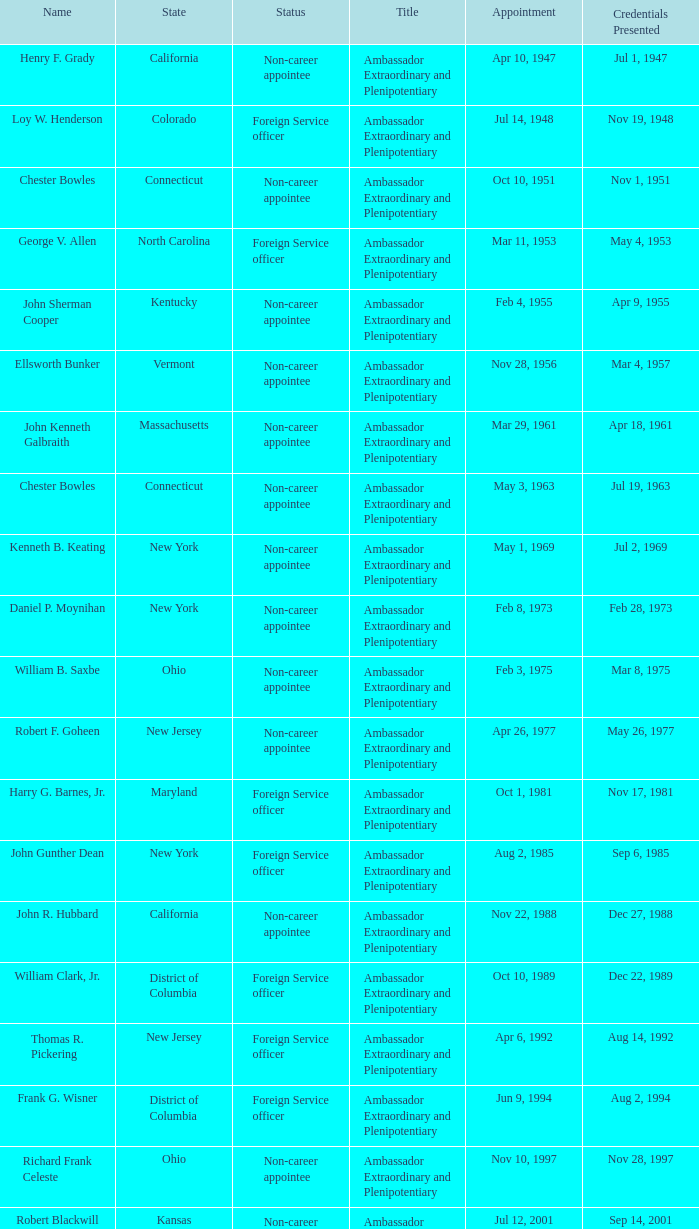What state has an appointment for jul 12, 2001? Kansas. 